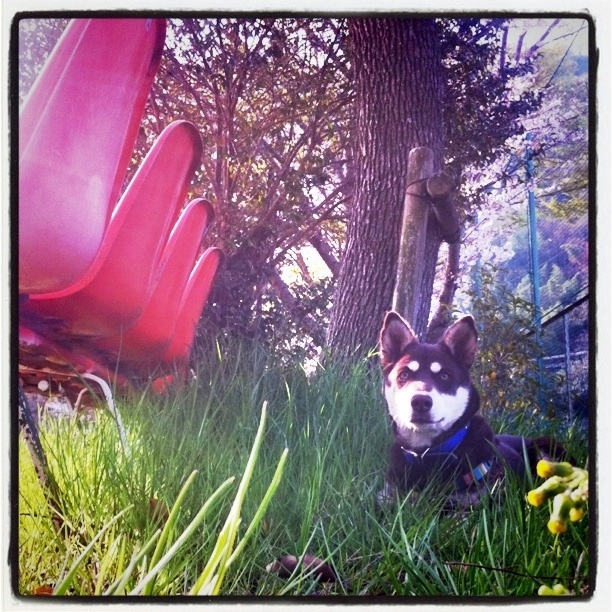Describe the objects in this image and their specific colors. I can see chair in white, violet, and purple tones, dog in white, navy, purple, black, and lavender tones, chair in white, violet, and brown tones, chair in white, gray, violet, brown, and purple tones, and chair in white, violet, salmon, brown, and purple tones in this image. 